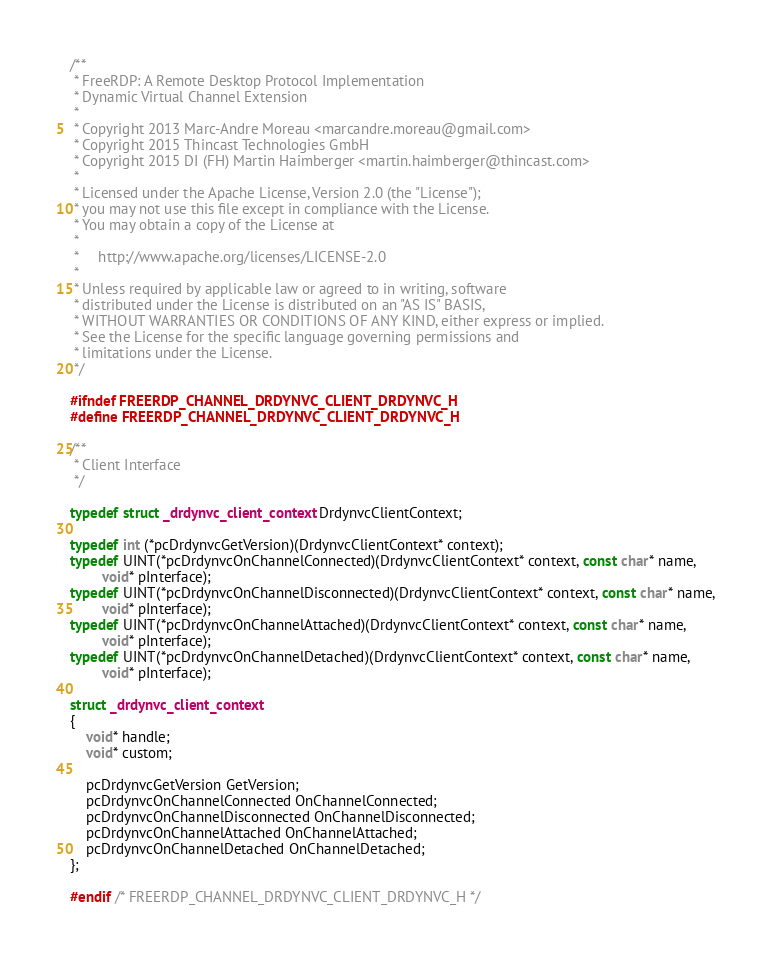<code> <loc_0><loc_0><loc_500><loc_500><_C_>/**
 * FreeRDP: A Remote Desktop Protocol Implementation
 * Dynamic Virtual Channel Extension
 *
 * Copyright 2013 Marc-Andre Moreau <marcandre.moreau@gmail.com>
 * Copyright 2015 Thincast Technologies GmbH
 * Copyright 2015 DI (FH) Martin Haimberger <martin.haimberger@thincast.com>
 *
 * Licensed under the Apache License, Version 2.0 (the "License");
 * you may not use this file except in compliance with the License.
 * You may obtain a copy of the License at
 *
 *     http://www.apache.org/licenses/LICENSE-2.0
 *
 * Unless required by applicable law or agreed to in writing, software
 * distributed under the License is distributed on an "AS IS" BASIS,
 * WITHOUT WARRANTIES OR CONDITIONS OF ANY KIND, either express or implied.
 * See the License for the specific language governing permissions and
 * limitations under the License.
 */

#ifndef FREERDP_CHANNEL_DRDYNVC_CLIENT_DRDYNVC_H
#define FREERDP_CHANNEL_DRDYNVC_CLIENT_DRDYNVC_H

/**
 * Client Interface
 */

typedef struct _drdynvc_client_context DrdynvcClientContext;

typedef int (*pcDrdynvcGetVersion)(DrdynvcClientContext* context);
typedef UINT(*pcDrdynvcOnChannelConnected)(DrdynvcClientContext* context, const char* name,
        void* pInterface);
typedef UINT(*pcDrdynvcOnChannelDisconnected)(DrdynvcClientContext* context, const char* name,
        void* pInterface);
typedef UINT(*pcDrdynvcOnChannelAttached)(DrdynvcClientContext* context, const char* name,
        void* pInterface);
typedef UINT(*pcDrdynvcOnChannelDetached)(DrdynvcClientContext* context, const char* name,
        void* pInterface);

struct _drdynvc_client_context
{
	void* handle;
	void* custom;

	pcDrdynvcGetVersion GetVersion;
	pcDrdynvcOnChannelConnected OnChannelConnected;
	pcDrdynvcOnChannelDisconnected OnChannelDisconnected;
	pcDrdynvcOnChannelAttached OnChannelAttached;
	pcDrdynvcOnChannelDetached OnChannelDetached;
};

#endif /* FREERDP_CHANNEL_DRDYNVC_CLIENT_DRDYNVC_H */
</code> 